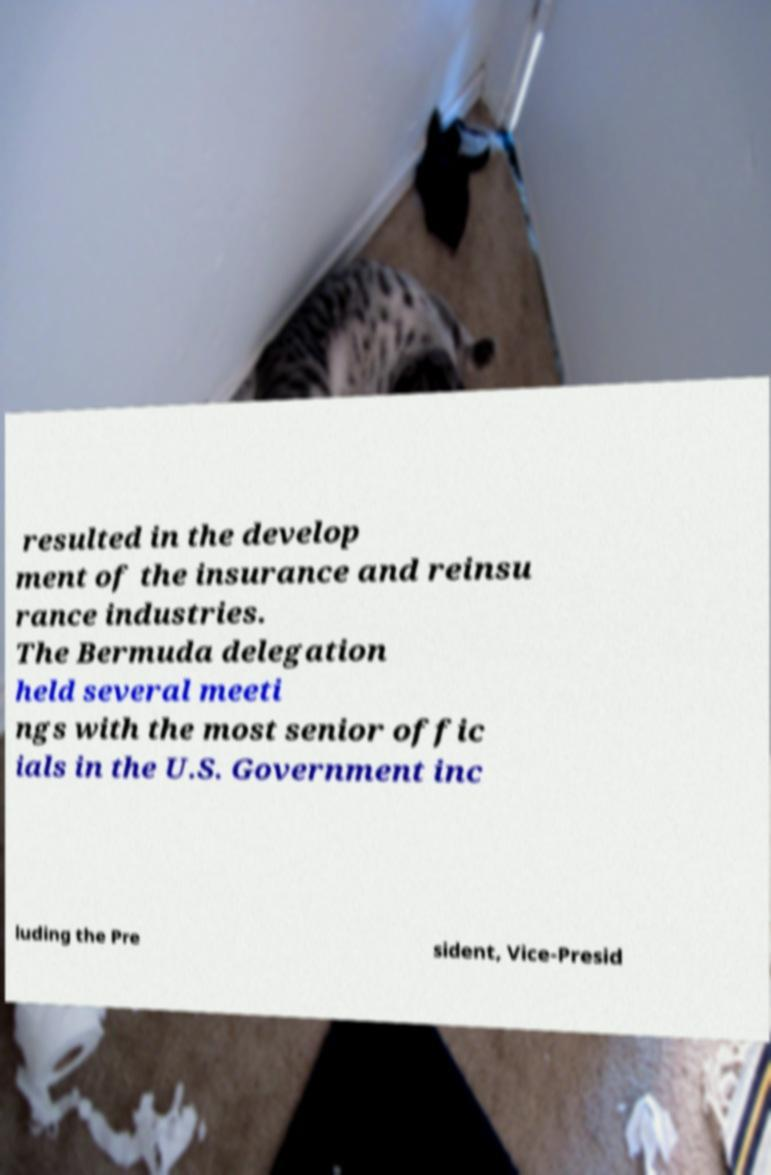Can you accurately transcribe the text from the provided image for me? resulted in the develop ment of the insurance and reinsu rance industries. The Bermuda delegation held several meeti ngs with the most senior offic ials in the U.S. Government inc luding the Pre sident, Vice-Presid 